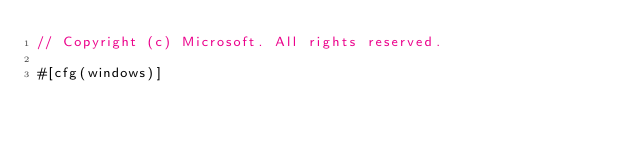<code> <loc_0><loc_0><loc_500><loc_500><_Rust_>// Copyright (c) Microsoft. All rights reserved.

#[cfg(windows)]</code> 